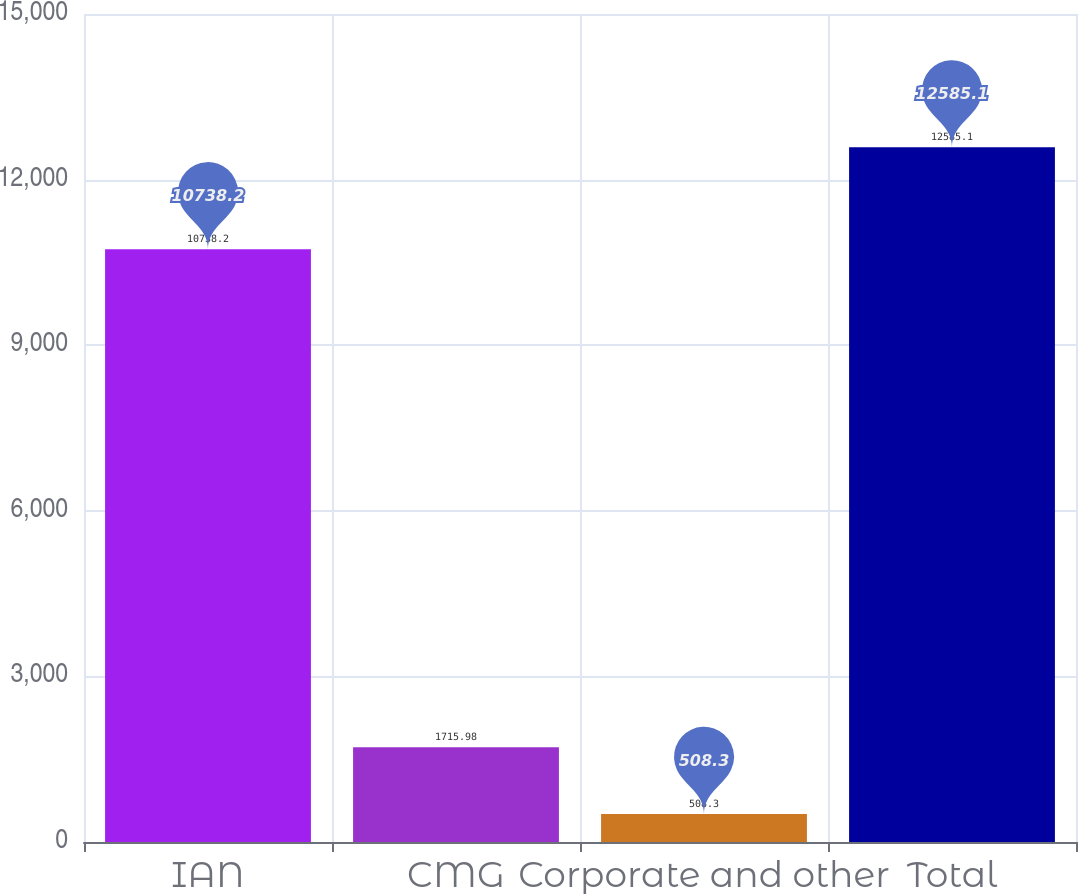<chart> <loc_0><loc_0><loc_500><loc_500><bar_chart><fcel>IAN<fcel>CMG<fcel>Corporate and other<fcel>Total<nl><fcel>10738.2<fcel>1715.98<fcel>508.3<fcel>12585.1<nl></chart> 